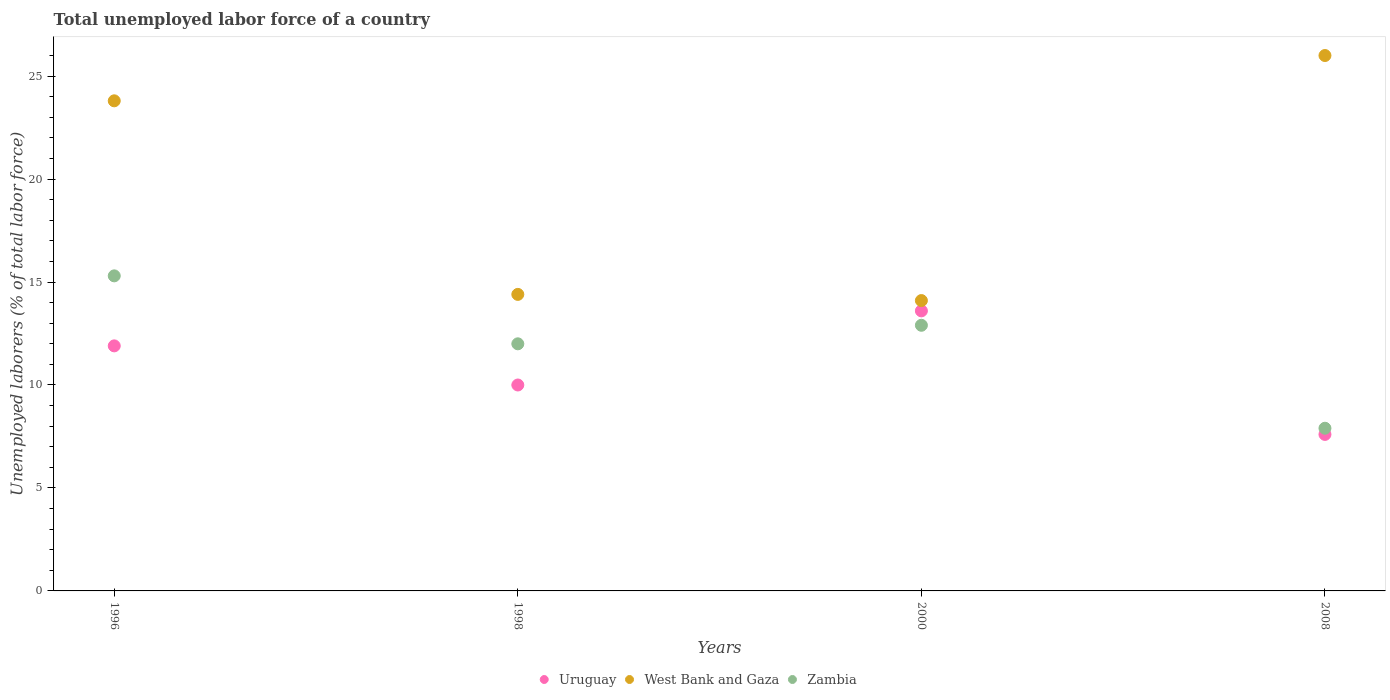Is the number of dotlines equal to the number of legend labels?
Ensure brevity in your answer.  Yes. What is the total unemployed labor force in West Bank and Gaza in 2000?
Your response must be concise. 14.1. Across all years, what is the maximum total unemployed labor force in Uruguay?
Offer a very short reply. 13.6. Across all years, what is the minimum total unemployed labor force in West Bank and Gaza?
Provide a succinct answer. 14.1. In which year was the total unemployed labor force in Zambia minimum?
Make the answer very short. 2008. What is the total total unemployed labor force in West Bank and Gaza in the graph?
Keep it short and to the point. 78.3. What is the difference between the total unemployed labor force in Zambia in 2000 and that in 2008?
Provide a short and direct response. 5. What is the difference between the total unemployed labor force in Zambia in 1996 and the total unemployed labor force in Uruguay in 2008?
Your response must be concise. 7.7. What is the average total unemployed labor force in Uruguay per year?
Provide a succinct answer. 10.77. In the year 1998, what is the difference between the total unemployed labor force in Uruguay and total unemployed labor force in Zambia?
Keep it short and to the point. -2. In how many years, is the total unemployed labor force in Uruguay greater than 8 %?
Provide a succinct answer. 3. What is the ratio of the total unemployed labor force in Uruguay in 1996 to that in 2008?
Keep it short and to the point. 1.57. Is the total unemployed labor force in Zambia in 1996 less than that in 1998?
Keep it short and to the point. No. Is the difference between the total unemployed labor force in Uruguay in 1996 and 2000 greater than the difference between the total unemployed labor force in Zambia in 1996 and 2000?
Offer a very short reply. No. What is the difference between the highest and the second highest total unemployed labor force in Uruguay?
Ensure brevity in your answer.  1.7. What is the difference between the highest and the lowest total unemployed labor force in Uruguay?
Ensure brevity in your answer.  6. Is it the case that in every year, the sum of the total unemployed labor force in Zambia and total unemployed labor force in Uruguay  is greater than the total unemployed labor force in West Bank and Gaza?
Your answer should be compact. No. Is the total unemployed labor force in West Bank and Gaza strictly less than the total unemployed labor force in Zambia over the years?
Provide a succinct answer. No. How many years are there in the graph?
Ensure brevity in your answer.  4. What is the difference between two consecutive major ticks on the Y-axis?
Give a very brief answer. 5. Does the graph contain any zero values?
Ensure brevity in your answer.  No. How many legend labels are there?
Provide a short and direct response. 3. How are the legend labels stacked?
Your answer should be very brief. Horizontal. What is the title of the graph?
Keep it short and to the point. Total unemployed labor force of a country. Does "Algeria" appear as one of the legend labels in the graph?
Ensure brevity in your answer.  No. What is the label or title of the X-axis?
Your answer should be compact. Years. What is the label or title of the Y-axis?
Ensure brevity in your answer.  Unemployed laborers (% of total labor force). What is the Unemployed laborers (% of total labor force) in Uruguay in 1996?
Provide a short and direct response. 11.9. What is the Unemployed laborers (% of total labor force) of West Bank and Gaza in 1996?
Give a very brief answer. 23.8. What is the Unemployed laborers (% of total labor force) in Zambia in 1996?
Make the answer very short. 15.3. What is the Unemployed laborers (% of total labor force) of Uruguay in 1998?
Provide a succinct answer. 10. What is the Unemployed laborers (% of total labor force) of West Bank and Gaza in 1998?
Make the answer very short. 14.4. What is the Unemployed laborers (% of total labor force) of Uruguay in 2000?
Offer a terse response. 13.6. What is the Unemployed laborers (% of total labor force) in West Bank and Gaza in 2000?
Give a very brief answer. 14.1. What is the Unemployed laborers (% of total labor force) of Zambia in 2000?
Provide a short and direct response. 12.9. What is the Unemployed laborers (% of total labor force) in Uruguay in 2008?
Your answer should be compact. 7.6. What is the Unemployed laborers (% of total labor force) in West Bank and Gaza in 2008?
Your response must be concise. 26. What is the Unemployed laborers (% of total labor force) in Zambia in 2008?
Make the answer very short. 7.9. Across all years, what is the maximum Unemployed laborers (% of total labor force) in Uruguay?
Your answer should be very brief. 13.6. Across all years, what is the maximum Unemployed laborers (% of total labor force) in Zambia?
Provide a succinct answer. 15.3. Across all years, what is the minimum Unemployed laborers (% of total labor force) of Uruguay?
Give a very brief answer. 7.6. Across all years, what is the minimum Unemployed laborers (% of total labor force) in West Bank and Gaza?
Provide a succinct answer. 14.1. Across all years, what is the minimum Unemployed laborers (% of total labor force) in Zambia?
Offer a terse response. 7.9. What is the total Unemployed laborers (% of total labor force) in Uruguay in the graph?
Give a very brief answer. 43.1. What is the total Unemployed laborers (% of total labor force) in West Bank and Gaza in the graph?
Provide a succinct answer. 78.3. What is the total Unemployed laborers (% of total labor force) in Zambia in the graph?
Make the answer very short. 48.1. What is the difference between the Unemployed laborers (% of total labor force) of Uruguay in 1996 and that in 2000?
Offer a terse response. -1.7. What is the difference between the Unemployed laborers (% of total labor force) of Zambia in 1996 and that in 2000?
Provide a succinct answer. 2.4. What is the difference between the Unemployed laborers (% of total labor force) in Uruguay in 1996 and that in 2008?
Provide a short and direct response. 4.3. What is the difference between the Unemployed laborers (% of total labor force) of West Bank and Gaza in 1996 and that in 2008?
Your answer should be compact. -2.2. What is the difference between the Unemployed laborers (% of total labor force) of Zambia in 1998 and that in 2000?
Offer a very short reply. -0.9. What is the difference between the Unemployed laborers (% of total labor force) of Uruguay in 1998 and that in 2008?
Provide a short and direct response. 2.4. What is the difference between the Unemployed laborers (% of total labor force) of West Bank and Gaza in 1998 and that in 2008?
Provide a succinct answer. -11.6. What is the difference between the Unemployed laborers (% of total labor force) in Zambia in 1998 and that in 2008?
Ensure brevity in your answer.  4.1. What is the difference between the Unemployed laborers (% of total labor force) of Uruguay in 2000 and that in 2008?
Offer a terse response. 6. What is the difference between the Unemployed laborers (% of total labor force) in Zambia in 2000 and that in 2008?
Give a very brief answer. 5. What is the difference between the Unemployed laborers (% of total labor force) in Uruguay in 1996 and the Unemployed laborers (% of total labor force) in West Bank and Gaza in 2000?
Ensure brevity in your answer.  -2.2. What is the difference between the Unemployed laborers (% of total labor force) of West Bank and Gaza in 1996 and the Unemployed laborers (% of total labor force) of Zambia in 2000?
Give a very brief answer. 10.9. What is the difference between the Unemployed laborers (% of total labor force) of Uruguay in 1996 and the Unemployed laborers (% of total labor force) of West Bank and Gaza in 2008?
Your response must be concise. -14.1. What is the difference between the Unemployed laborers (% of total labor force) of Uruguay in 1998 and the Unemployed laborers (% of total labor force) of West Bank and Gaza in 2000?
Ensure brevity in your answer.  -4.1. What is the difference between the Unemployed laborers (% of total labor force) in West Bank and Gaza in 1998 and the Unemployed laborers (% of total labor force) in Zambia in 2000?
Make the answer very short. 1.5. What is the difference between the Unemployed laborers (% of total labor force) of Uruguay in 1998 and the Unemployed laborers (% of total labor force) of Zambia in 2008?
Provide a short and direct response. 2.1. What is the difference between the Unemployed laborers (% of total labor force) of West Bank and Gaza in 1998 and the Unemployed laborers (% of total labor force) of Zambia in 2008?
Offer a terse response. 6.5. What is the difference between the Unemployed laborers (% of total labor force) in Uruguay in 2000 and the Unemployed laborers (% of total labor force) in West Bank and Gaza in 2008?
Make the answer very short. -12.4. What is the difference between the Unemployed laborers (% of total labor force) in Uruguay in 2000 and the Unemployed laborers (% of total labor force) in Zambia in 2008?
Your answer should be very brief. 5.7. What is the average Unemployed laborers (% of total labor force) in Uruguay per year?
Provide a succinct answer. 10.78. What is the average Unemployed laborers (% of total labor force) of West Bank and Gaza per year?
Give a very brief answer. 19.57. What is the average Unemployed laborers (% of total labor force) of Zambia per year?
Give a very brief answer. 12.03. In the year 1996, what is the difference between the Unemployed laborers (% of total labor force) of Uruguay and Unemployed laborers (% of total labor force) of Zambia?
Give a very brief answer. -3.4. In the year 1998, what is the difference between the Unemployed laborers (% of total labor force) of West Bank and Gaza and Unemployed laborers (% of total labor force) of Zambia?
Your response must be concise. 2.4. In the year 2000, what is the difference between the Unemployed laborers (% of total labor force) of West Bank and Gaza and Unemployed laborers (% of total labor force) of Zambia?
Ensure brevity in your answer.  1.2. In the year 2008, what is the difference between the Unemployed laborers (% of total labor force) of Uruguay and Unemployed laborers (% of total labor force) of West Bank and Gaza?
Provide a short and direct response. -18.4. In the year 2008, what is the difference between the Unemployed laborers (% of total labor force) in Uruguay and Unemployed laborers (% of total labor force) in Zambia?
Your response must be concise. -0.3. What is the ratio of the Unemployed laborers (% of total labor force) in Uruguay in 1996 to that in 1998?
Your response must be concise. 1.19. What is the ratio of the Unemployed laborers (% of total labor force) in West Bank and Gaza in 1996 to that in 1998?
Make the answer very short. 1.65. What is the ratio of the Unemployed laborers (% of total labor force) of Zambia in 1996 to that in 1998?
Make the answer very short. 1.27. What is the ratio of the Unemployed laborers (% of total labor force) in West Bank and Gaza in 1996 to that in 2000?
Your answer should be very brief. 1.69. What is the ratio of the Unemployed laborers (% of total labor force) in Zambia in 1996 to that in 2000?
Make the answer very short. 1.19. What is the ratio of the Unemployed laborers (% of total labor force) in Uruguay in 1996 to that in 2008?
Give a very brief answer. 1.57. What is the ratio of the Unemployed laborers (% of total labor force) of West Bank and Gaza in 1996 to that in 2008?
Offer a very short reply. 0.92. What is the ratio of the Unemployed laborers (% of total labor force) in Zambia in 1996 to that in 2008?
Provide a succinct answer. 1.94. What is the ratio of the Unemployed laborers (% of total labor force) in Uruguay in 1998 to that in 2000?
Provide a short and direct response. 0.74. What is the ratio of the Unemployed laborers (% of total labor force) in West Bank and Gaza in 1998 to that in 2000?
Provide a short and direct response. 1.02. What is the ratio of the Unemployed laborers (% of total labor force) of Zambia in 1998 to that in 2000?
Make the answer very short. 0.93. What is the ratio of the Unemployed laborers (% of total labor force) in Uruguay in 1998 to that in 2008?
Give a very brief answer. 1.32. What is the ratio of the Unemployed laborers (% of total labor force) in West Bank and Gaza in 1998 to that in 2008?
Offer a very short reply. 0.55. What is the ratio of the Unemployed laborers (% of total labor force) of Zambia in 1998 to that in 2008?
Make the answer very short. 1.52. What is the ratio of the Unemployed laborers (% of total labor force) in Uruguay in 2000 to that in 2008?
Ensure brevity in your answer.  1.79. What is the ratio of the Unemployed laborers (% of total labor force) of West Bank and Gaza in 2000 to that in 2008?
Make the answer very short. 0.54. What is the ratio of the Unemployed laborers (% of total labor force) of Zambia in 2000 to that in 2008?
Offer a terse response. 1.63. What is the difference between the highest and the lowest Unemployed laborers (% of total labor force) of Uruguay?
Offer a very short reply. 6. 